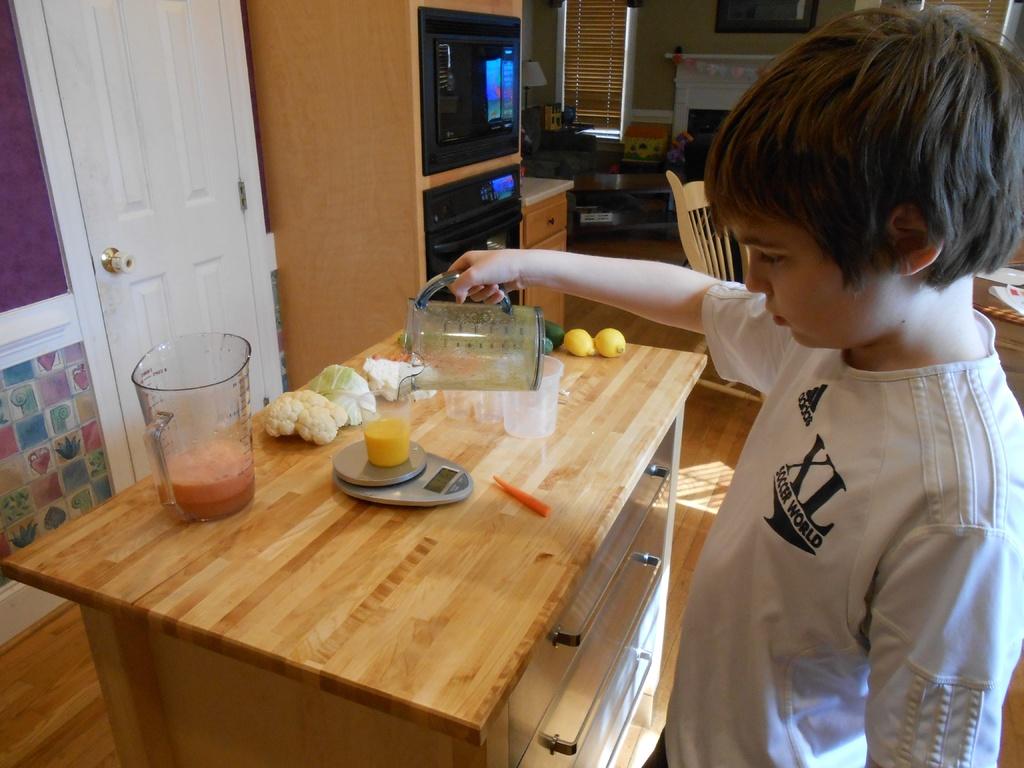What brand is on the boy's shirt?
Provide a succinct answer. Adidas. 